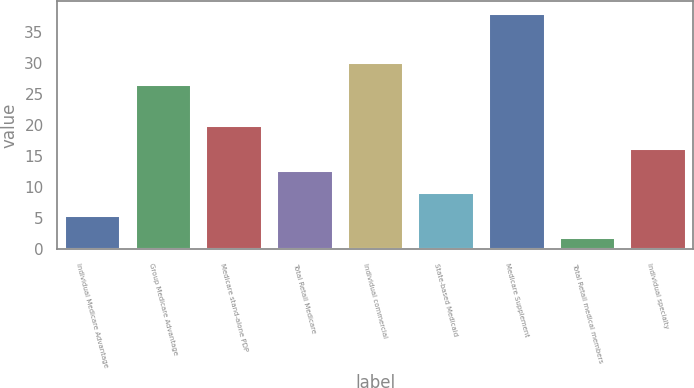<chart> <loc_0><loc_0><loc_500><loc_500><bar_chart><fcel>Individual Medicare Advantage<fcel>Group Medicare Advantage<fcel>Medicare stand-alone PDP<fcel>Total Retail Medicare<fcel>Individual commercial<fcel>State-based Medicaid<fcel>Medicare Supplement<fcel>Total Retail medical members<fcel>Individual specialty<nl><fcel>5.51<fcel>26.6<fcel>19.95<fcel>12.73<fcel>30.21<fcel>9.12<fcel>38<fcel>1.9<fcel>16.34<nl></chart> 